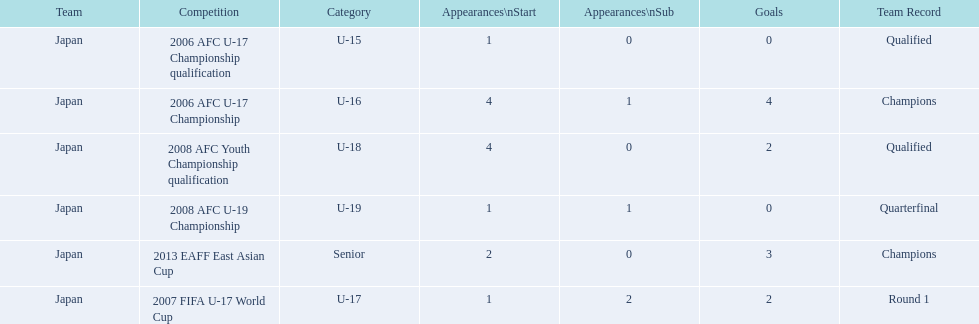What competitions did japan compete in with yoichiro kakitani? 2006 AFC U-17 Championship qualification, 2006 AFC U-17 Championship, 2007 FIFA U-17 World Cup, 2008 AFC Youth Championship qualification, 2008 AFC U-19 Championship, 2013 EAFF East Asian Cup. Of those competitions, which were held in 2007 and 2013? 2007 FIFA U-17 World Cup, 2013 EAFF East Asian Cup. Of the 2007 fifa u-17 world cup and the 2013 eaff east asian cup, which did japan have the most starting appearances? 2013 EAFF East Asian Cup. 